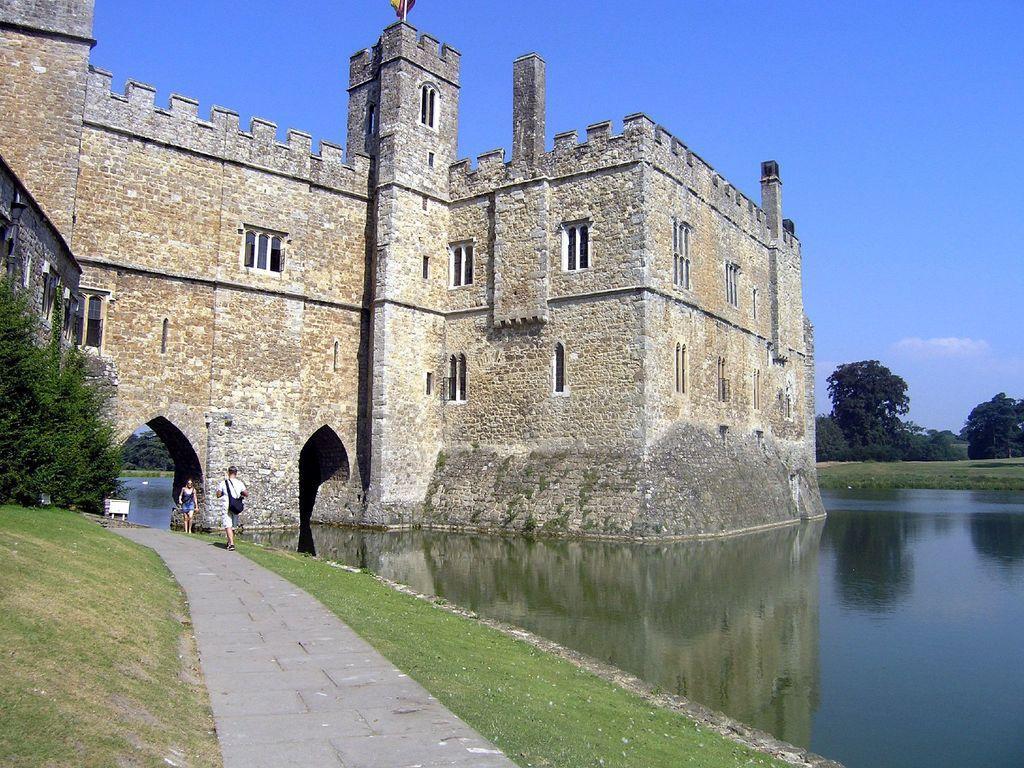How would you summarize this image in a sentence or two? In the picture I can see two persons standing and there is a greenery ground on either sides of them and there are few trees in the left corner and there is water in the right corner and there is a building which is made of bricks in the background. 